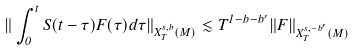<formula> <loc_0><loc_0><loc_500><loc_500>\| \int _ { 0 } ^ { t } S ( t - \tau ) F ( \tau ) d \tau \| _ { X ^ { s , b } _ { T } ( M ) } \lesssim T ^ { 1 - b - b ^ { \prime } } \| F \| _ { X ^ { s , - b ^ { \prime } } _ { T } ( M ) }</formula> 